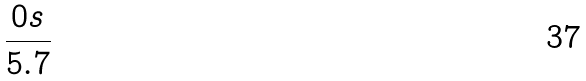Convert formula to latex. <formula><loc_0><loc_0><loc_500><loc_500>\frac { 0 s } { 5 . 7 }</formula> 